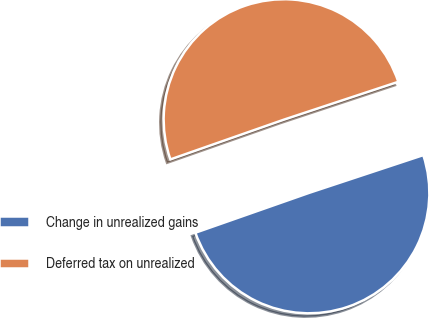<chart> <loc_0><loc_0><loc_500><loc_500><pie_chart><fcel>Change in unrealized gains<fcel>Deferred tax on unrealized<nl><fcel>49.72%<fcel>50.28%<nl></chart> 